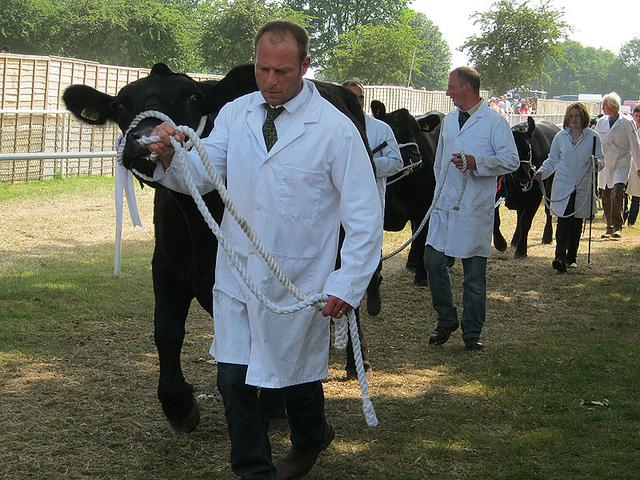Who are these grownups? doctors 